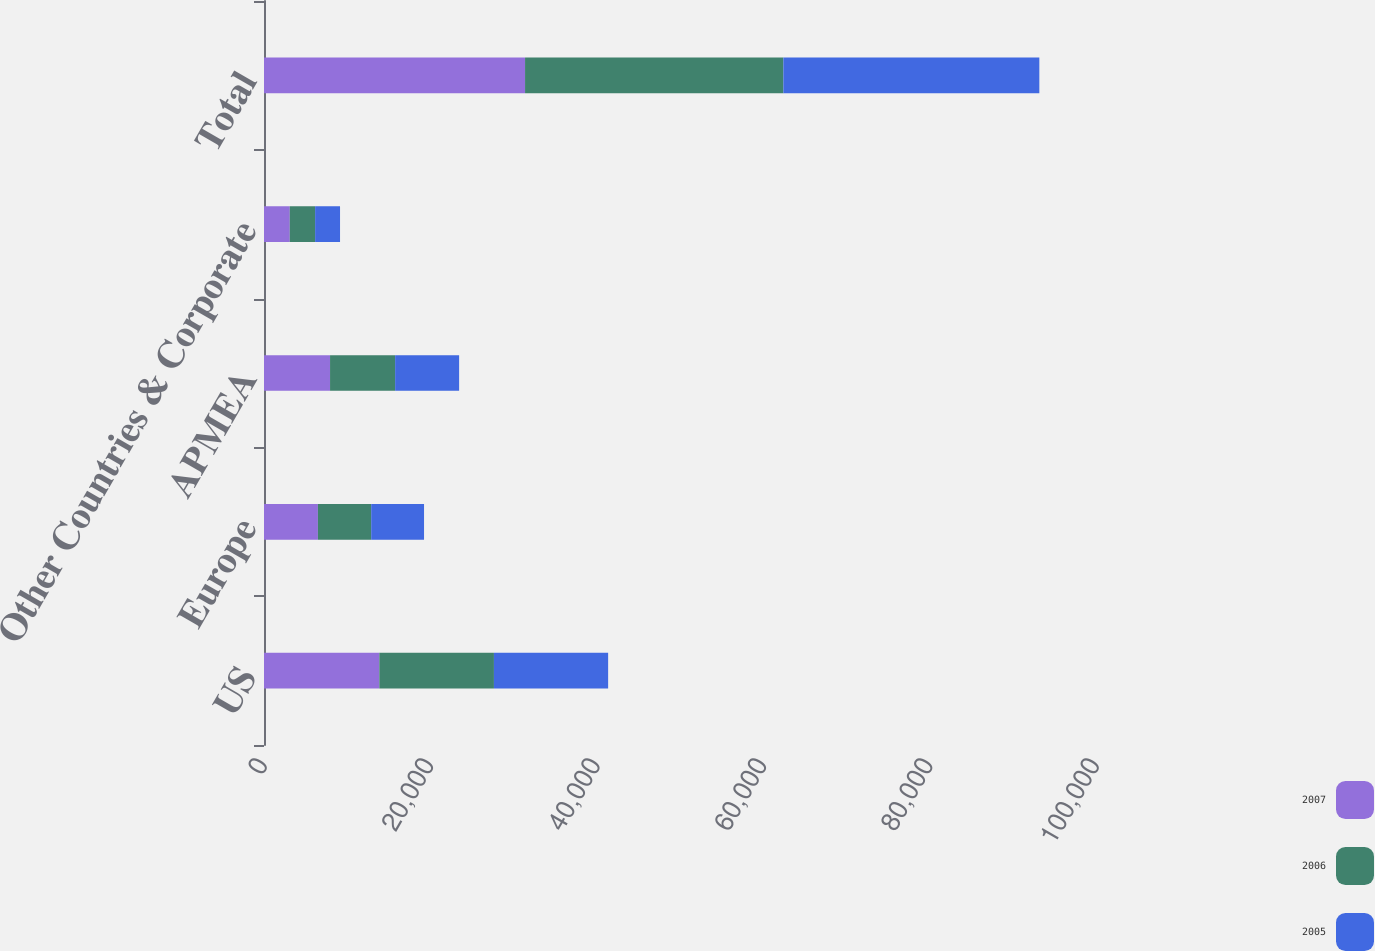Convert chart. <chart><loc_0><loc_0><loc_500><loc_500><stacked_bar_chart><ecel><fcel>US<fcel>Europe<fcel>APMEA<fcel>Other Countries & Corporate<fcel>Total<nl><fcel>2007<fcel>13862<fcel>6480<fcel>7938<fcel>3097<fcel>31377<nl><fcel>2006<fcel>13774<fcel>6403<fcel>7822<fcel>3047<fcel>31046<nl><fcel>2005<fcel>13727<fcel>6352<fcel>7692<fcel>2995<fcel>30766<nl></chart> 